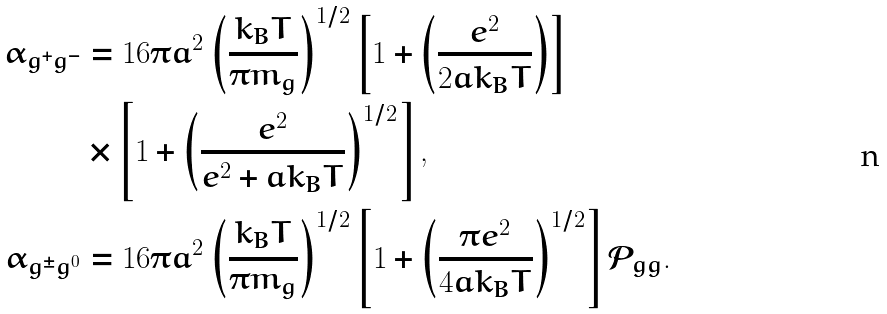Convert formula to latex. <formula><loc_0><loc_0><loc_500><loc_500>\alpha _ { g ^ { + } g ^ { - } } & = 1 6 \pi a ^ { 2 } \left ( \frac { k _ { B } T } { \pi m _ { g } } \right ) ^ { 1 / 2 } \left [ 1 + \left ( \frac { e ^ { 2 } } { 2 a k _ { B } T } \right ) \right ] \\ & \times \left [ 1 + \left ( \frac { e ^ { 2 } } { e ^ { 2 } + a k _ { B } T } \right ) ^ { 1 / 2 } \right ] , \\ \alpha _ { g ^ { \pm } g ^ { 0 } } & = 1 6 \pi a ^ { 2 } \left ( \frac { k _ { B } T } { \pi m _ { g } } \right ) ^ { 1 / 2 } \left [ 1 + \left ( \frac { \pi e ^ { 2 } } { 4 a k _ { B } T } \right ) ^ { 1 / 2 } \right ] \mathcal { P } _ { g g } .</formula> 